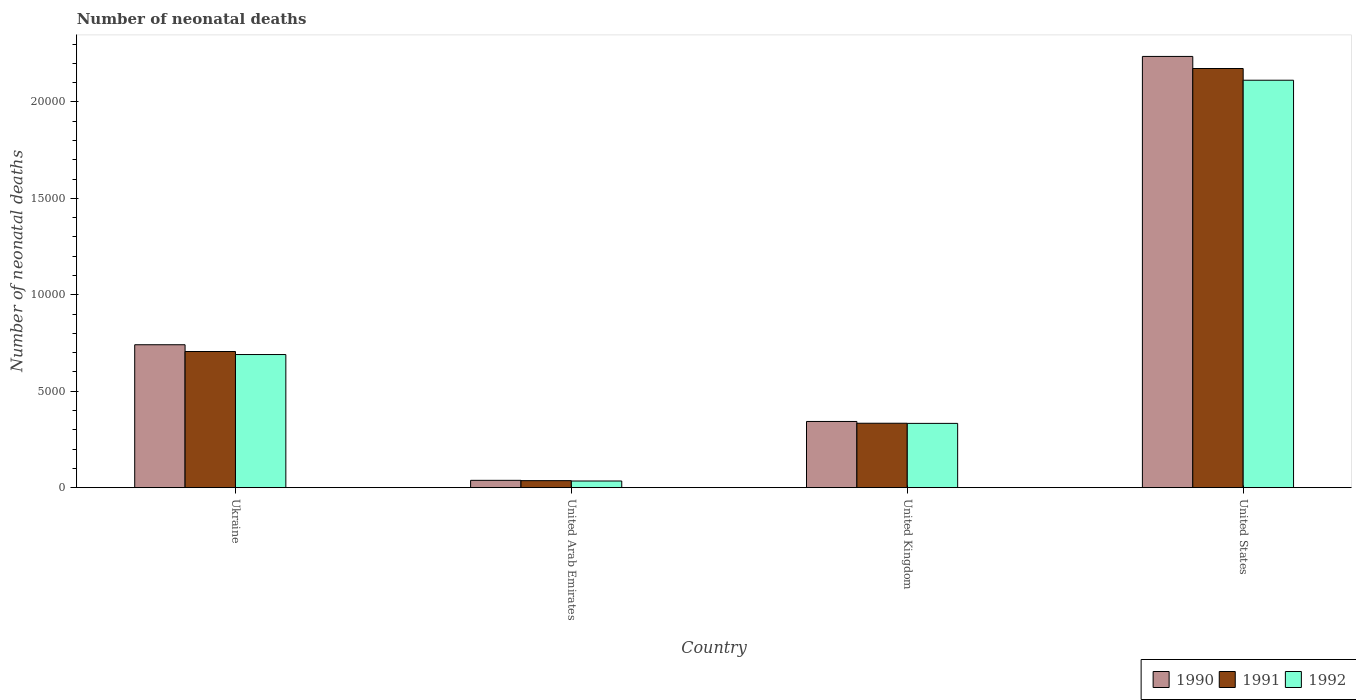How many groups of bars are there?
Offer a very short reply. 4. Are the number of bars on each tick of the X-axis equal?
Provide a short and direct response. Yes. How many bars are there on the 2nd tick from the left?
Your answer should be very brief. 3. What is the label of the 1st group of bars from the left?
Make the answer very short. Ukraine. In how many cases, is the number of bars for a given country not equal to the number of legend labels?
Provide a succinct answer. 0. What is the number of neonatal deaths in in 1991 in United Arab Emirates?
Offer a very short reply. 363. Across all countries, what is the maximum number of neonatal deaths in in 1992?
Your answer should be compact. 2.11e+04. Across all countries, what is the minimum number of neonatal deaths in in 1992?
Your answer should be very brief. 344. In which country was the number of neonatal deaths in in 1991 minimum?
Offer a terse response. United Arab Emirates. What is the total number of neonatal deaths in in 1991 in the graph?
Ensure brevity in your answer.  3.25e+04. What is the difference between the number of neonatal deaths in in 1992 in United Kingdom and that in United States?
Your answer should be compact. -1.78e+04. What is the difference between the number of neonatal deaths in in 1992 in United States and the number of neonatal deaths in in 1990 in Ukraine?
Provide a succinct answer. 1.37e+04. What is the average number of neonatal deaths in in 1991 per country?
Provide a short and direct response. 8123.75. What is the difference between the number of neonatal deaths in of/in 1992 and number of neonatal deaths in of/in 1991 in United States?
Offer a very short reply. -608. In how many countries, is the number of neonatal deaths in in 1991 greater than 9000?
Keep it short and to the point. 1. What is the ratio of the number of neonatal deaths in in 1992 in Ukraine to that in United States?
Provide a short and direct response. 0.33. Is the number of neonatal deaths in in 1990 in Ukraine less than that in United Kingdom?
Make the answer very short. No. Is the difference between the number of neonatal deaths in in 1992 in Ukraine and United Kingdom greater than the difference between the number of neonatal deaths in in 1991 in Ukraine and United Kingdom?
Make the answer very short. No. What is the difference between the highest and the second highest number of neonatal deaths in in 1992?
Your response must be concise. -3570. What is the difference between the highest and the lowest number of neonatal deaths in in 1992?
Your answer should be compact. 2.08e+04. Is the sum of the number of neonatal deaths in in 1991 in Ukraine and United Arab Emirates greater than the maximum number of neonatal deaths in in 1992 across all countries?
Your answer should be compact. No. What does the 3rd bar from the right in Ukraine represents?
Offer a very short reply. 1990. Is it the case that in every country, the sum of the number of neonatal deaths in in 1990 and number of neonatal deaths in in 1992 is greater than the number of neonatal deaths in in 1991?
Make the answer very short. Yes. How many legend labels are there?
Your answer should be very brief. 3. How are the legend labels stacked?
Offer a terse response. Horizontal. What is the title of the graph?
Provide a short and direct response. Number of neonatal deaths. Does "2010" appear as one of the legend labels in the graph?
Your answer should be compact. No. What is the label or title of the Y-axis?
Ensure brevity in your answer.  Number of neonatal deaths. What is the Number of neonatal deaths in 1990 in Ukraine?
Keep it short and to the point. 7410. What is the Number of neonatal deaths in 1991 in Ukraine?
Your answer should be very brief. 7059. What is the Number of neonatal deaths of 1992 in Ukraine?
Provide a short and direct response. 6902. What is the Number of neonatal deaths of 1990 in United Arab Emirates?
Your answer should be very brief. 379. What is the Number of neonatal deaths of 1991 in United Arab Emirates?
Ensure brevity in your answer.  363. What is the Number of neonatal deaths of 1992 in United Arab Emirates?
Give a very brief answer. 344. What is the Number of neonatal deaths of 1990 in United Kingdom?
Make the answer very short. 3432. What is the Number of neonatal deaths in 1991 in United Kingdom?
Offer a very short reply. 3339. What is the Number of neonatal deaths in 1992 in United Kingdom?
Give a very brief answer. 3332. What is the Number of neonatal deaths of 1990 in United States?
Make the answer very short. 2.24e+04. What is the Number of neonatal deaths in 1991 in United States?
Your answer should be very brief. 2.17e+04. What is the Number of neonatal deaths of 1992 in United States?
Provide a short and direct response. 2.11e+04. Across all countries, what is the maximum Number of neonatal deaths of 1990?
Offer a terse response. 2.24e+04. Across all countries, what is the maximum Number of neonatal deaths in 1991?
Provide a short and direct response. 2.17e+04. Across all countries, what is the maximum Number of neonatal deaths of 1992?
Keep it short and to the point. 2.11e+04. Across all countries, what is the minimum Number of neonatal deaths in 1990?
Your answer should be compact. 379. Across all countries, what is the minimum Number of neonatal deaths of 1991?
Offer a very short reply. 363. Across all countries, what is the minimum Number of neonatal deaths of 1992?
Keep it short and to the point. 344. What is the total Number of neonatal deaths in 1990 in the graph?
Offer a terse response. 3.36e+04. What is the total Number of neonatal deaths of 1991 in the graph?
Ensure brevity in your answer.  3.25e+04. What is the total Number of neonatal deaths in 1992 in the graph?
Your response must be concise. 3.17e+04. What is the difference between the Number of neonatal deaths of 1990 in Ukraine and that in United Arab Emirates?
Give a very brief answer. 7031. What is the difference between the Number of neonatal deaths of 1991 in Ukraine and that in United Arab Emirates?
Keep it short and to the point. 6696. What is the difference between the Number of neonatal deaths in 1992 in Ukraine and that in United Arab Emirates?
Your answer should be very brief. 6558. What is the difference between the Number of neonatal deaths of 1990 in Ukraine and that in United Kingdom?
Give a very brief answer. 3978. What is the difference between the Number of neonatal deaths of 1991 in Ukraine and that in United Kingdom?
Make the answer very short. 3720. What is the difference between the Number of neonatal deaths of 1992 in Ukraine and that in United Kingdom?
Your answer should be compact. 3570. What is the difference between the Number of neonatal deaths in 1990 in Ukraine and that in United States?
Provide a succinct answer. -1.50e+04. What is the difference between the Number of neonatal deaths of 1991 in Ukraine and that in United States?
Your response must be concise. -1.47e+04. What is the difference between the Number of neonatal deaths of 1992 in Ukraine and that in United States?
Offer a terse response. -1.42e+04. What is the difference between the Number of neonatal deaths of 1990 in United Arab Emirates and that in United Kingdom?
Your response must be concise. -3053. What is the difference between the Number of neonatal deaths of 1991 in United Arab Emirates and that in United Kingdom?
Provide a short and direct response. -2976. What is the difference between the Number of neonatal deaths of 1992 in United Arab Emirates and that in United Kingdom?
Offer a terse response. -2988. What is the difference between the Number of neonatal deaths in 1990 in United Arab Emirates and that in United States?
Offer a very short reply. -2.20e+04. What is the difference between the Number of neonatal deaths in 1991 in United Arab Emirates and that in United States?
Your answer should be very brief. -2.14e+04. What is the difference between the Number of neonatal deaths of 1992 in United Arab Emirates and that in United States?
Your response must be concise. -2.08e+04. What is the difference between the Number of neonatal deaths in 1990 in United Kingdom and that in United States?
Offer a terse response. -1.89e+04. What is the difference between the Number of neonatal deaths in 1991 in United Kingdom and that in United States?
Your response must be concise. -1.84e+04. What is the difference between the Number of neonatal deaths in 1992 in United Kingdom and that in United States?
Make the answer very short. -1.78e+04. What is the difference between the Number of neonatal deaths in 1990 in Ukraine and the Number of neonatal deaths in 1991 in United Arab Emirates?
Offer a terse response. 7047. What is the difference between the Number of neonatal deaths of 1990 in Ukraine and the Number of neonatal deaths of 1992 in United Arab Emirates?
Provide a succinct answer. 7066. What is the difference between the Number of neonatal deaths of 1991 in Ukraine and the Number of neonatal deaths of 1992 in United Arab Emirates?
Give a very brief answer. 6715. What is the difference between the Number of neonatal deaths of 1990 in Ukraine and the Number of neonatal deaths of 1991 in United Kingdom?
Your answer should be compact. 4071. What is the difference between the Number of neonatal deaths in 1990 in Ukraine and the Number of neonatal deaths in 1992 in United Kingdom?
Make the answer very short. 4078. What is the difference between the Number of neonatal deaths in 1991 in Ukraine and the Number of neonatal deaths in 1992 in United Kingdom?
Keep it short and to the point. 3727. What is the difference between the Number of neonatal deaths in 1990 in Ukraine and the Number of neonatal deaths in 1991 in United States?
Give a very brief answer. -1.43e+04. What is the difference between the Number of neonatal deaths in 1990 in Ukraine and the Number of neonatal deaths in 1992 in United States?
Give a very brief answer. -1.37e+04. What is the difference between the Number of neonatal deaths of 1991 in Ukraine and the Number of neonatal deaths of 1992 in United States?
Provide a short and direct response. -1.41e+04. What is the difference between the Number of neonatal deaths in 1990 in United Arab Emirates and the Number of neonatal deaths in 1991 in United Kingdom?
Ensure brevity in your answer.  -2960. What is the difference between the Number of neonatal deaths in 1990 in United Arab Emirates and the Number of neonatal deaths in 1992 in United Kingdom?
Your response must be concise. -2953. What is the difference between the Number of neonatal deaths in 1991 in United Arab Emirates and the Number of neonatal deaths in 1992 in United Kingdom?
Ensure brevity in your answer.  -2969. What is the difference between the Number of neonatal deaths of 1990 in United Arab Emirates and the Number of neonatal deaths of 1991 in United States?
Keep it short and to the point. -2.14e+04. What is the difference between the Number of neonatal deaths of 1990 in United Arab Emirates and the Number of neonatal deaths of 1992 in United States?
Provide a succinct answer. -2.07e+04. What is the difference between the Number of neonatal deaths of 1991 in United Arab Emirates and the Number of neonatal deaths of 1992 in United States?
Offer a very short reply. -2.08e+04. What is the difference between the Number of neonatal deaths in 1990 in United Kingdom and the Number of neonatal deaths in 1991 in United States?
Your answer should be compact. -1.83e+04. What is the difference between the Number of neonatal deaths of 1990 in United Kingdom and the Number of neonatal deaths of 1992 in United States?
Provide a succinct answer. -1.77e+04. What is the difference between the Number of neonatal deaths of 1991 in United Kingdom and the Number of neonatal deaths of 1992 in United States?
Your answer should be compact. -1.78e+04. What is the average Number of neonatal deaths of 1990 per country?
Offer a terse response. 8395.25. What is the average Number of neonatal deaths in 1991 per country?
Offer a terse response. 8123.75. What is the average Number of neonatal deaths in 1992 per country?
Offer a very short reply. 7926. What is the difference between the Number of neonatal deaths of 1990 and Number of neonatal deaths of 1991 in Ukraine?
Your answer should be compact. 351. What is the difference between the Number of neonatal deaths in 1990 and Number of neonatal deaths in 1992 in Ukraine?
Offer a terse response. 508. What is the difference between the Number of neonatal deaths in 1991 and Number of neonatal deaths in 1992 in Ukraine?
Provide a succinct answer. 157. What is the difference between the Number of neonatal deaths in 1990 and Number of neonatal deaths in 1991 in United Kingdom?
Your response must be concise. 93. What is the difference between the Number of neonatal deaths of 1990 and Number of neonatal deaths of 1991 in United States?
Ensure brevity in your answer.  626. What is the difference between the Number of neonatal deaths of 1990 and Number of neonatal deaths of 1992 in United States?
Give a very brief answer. 1234. What is the difference between the Number of neonatal deaths of 1991 and Number of neonatal deaths of 1992 in United States?
Offer a terse response. 608. What is the ratio of the Number of neonatal deaths in 1990 in Ukraine to that in United Arab Emirates?
Your answer should be very brief. 19.55. What is the ratio of the Number of neonatal deaths in 1991 in Ukraine to that in United Arab Emirates?
Provide a succinct answer. 19.45. What is the ratio of the Number of neonatal deaths of 1992 in Ukraine to that in United Arab Emirates?
Your answer should be very brief. 20.06. What is the ratio of the Number of neonatal deaths in 1990 in Ukraine to that in United Kingdom?
Your answer should be compact. 2.16. What is the ratio of the Number of neonatal deaths of 1991 in Ukraine to that in United Kingdom?
Ensure brevity in your answer.  2.11. What is the ratio of the Number of neonatal deaths of 1992 in Ukraine to that in United Kingdom?
Your answer should be compact. 2.07. What is the ratio of the Number of neonatal deaths of 1990 in Ukraine to that in United States?
Provide a succinct answer. 0.33. What is the ratio of the Number of neonatal deaths of 1991 in Ukraine to that in United States?
Give a very brief answer. 0.32. What is the ratio of the Number of neonatal deaths of 1992 in Ukraine to that in United States?
Provide a short and direct response. 0.33. What is the ratio of the Number of neonatal deaths in 1990 in United Arab Emirates to that in United Kingdom?
Your answer should be compact. 0.11. What is the ratio of the Number of neonatal deaths in 1991 in United Arab Emirates to that in United Kingdom?
Your answer should be very brief. 0.11. What is the ratio of the Number of neonatal deaths of 1992 in United Arab Emirates to that in United Kingdom?
Offer a very short reply. 0.1. What is the ratio of the Number of neonatal deaths of 1990 in United Arab Emirates to that in United States?
Give a very brief answer. 0.02. What is the ratio of the Number of neonatal deaths in 1991 in United Arab Emirates to that in United States?
Your answer should be compact. 0.02. What is the ratio of the Number of neonatal deaths of 1992 in United Arab Emirates to that in United States?
Make the answer very short. 0.02. What is the ratio of the Number of neonatal deaths of 1990 in United Kingdom to that in United States?
Provide a short and direct response. 0.15. What is the ratio of the Number of neonatal deaths in 1991 in United Kingdom to that in United States?
Provide a short and direct response. 0.15. What is the ratio of the Number of neonatal deaths in 1992 in United Kingdom to that in United States?
Your answer should be compact. 0.16. What is the difference between the highest and the second highest Number of neonatal deaths of 1990?
Your answer should be compact. 1.50e+04. What is the difference between the highest and the second highest Number of neonatal deaths in 1991?
Give a very brief answer. 1.47e+04. What is the difference between the highest and the second highest Number of neonatal deaths in 1992?
Your response must be concise. 1.42e+04. What is the difference between the highest and the lowest Number of neonatal deaths in 1990?
Provide a succinct answer. 2.20e+04. What is the difference between the highest and the lowest Number of neonatal deaths of 1991?
Keep it short and to the point. 2.14e+04. What is the difference between the highest and the lowest Number of neonatal deaths of 1992?
Your answer should be very brief. 2.08e+04. 